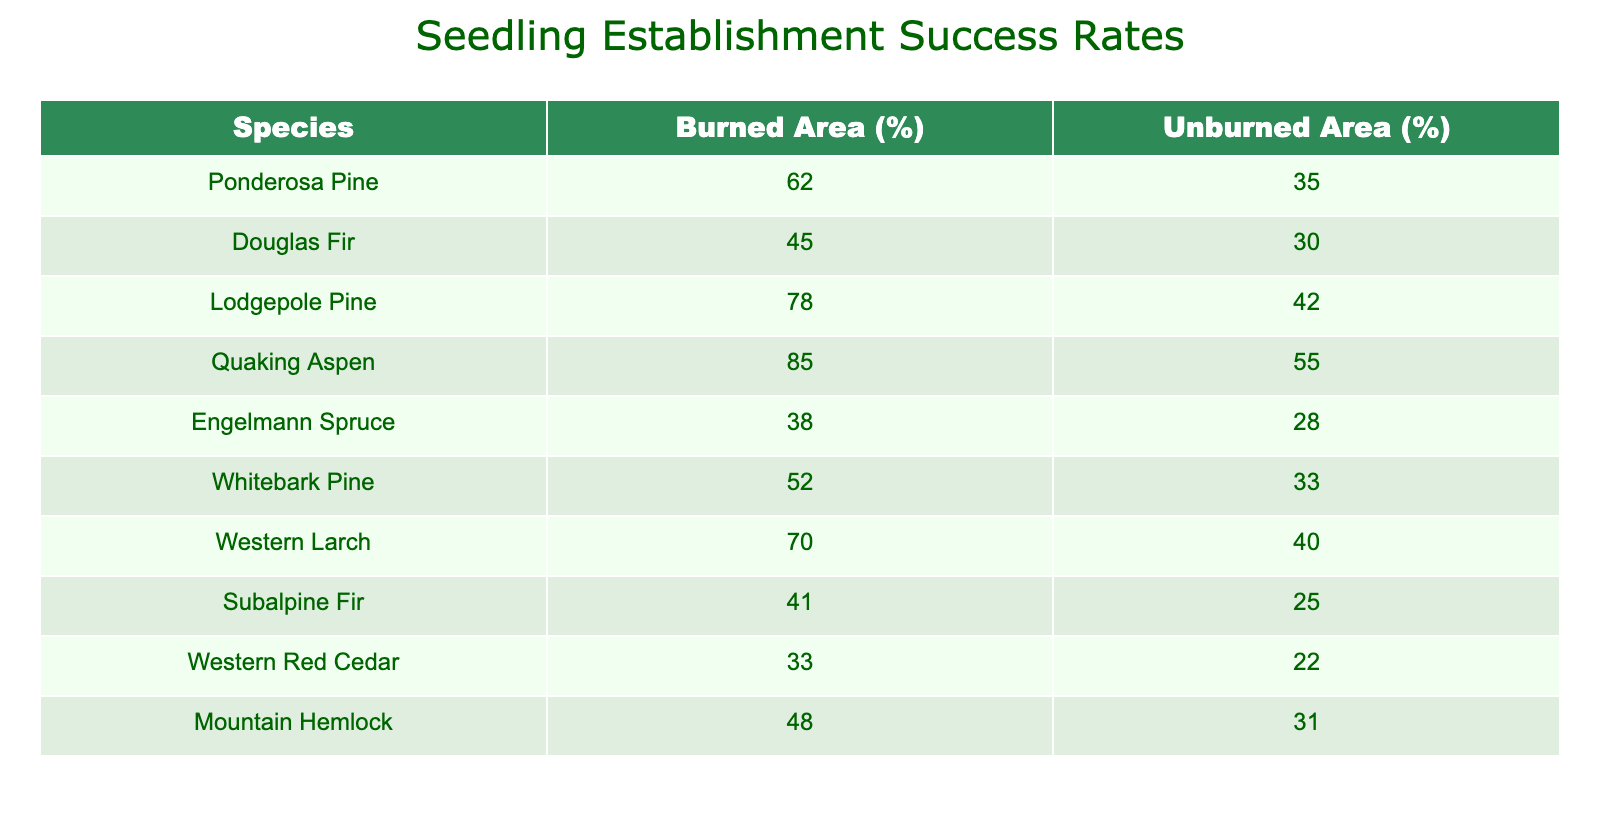What is the seedling establishment success rate for Quaking Aspen in burned areas? The table shows that the seedling establishment success rate for Quaking Aspen in burned areas is 85%.
Answer: 85 Which species has the highest seedling establishment success rate in unburned areas? The highest value in the "Unburned Area (%)" column is 55%, which corresponds to Quaking Aspen.
Answer: Quaking Aspen What is the difference in seedling establishment success rates between Lodgepole Pine in burned areas and in unburned areas? For Lodgepole Pine, the success rate in burned areas is 78% and in unburned areas is 42%. The difference is 78% - 42% = 36%.
Answer: 36 Do Engelmann Spruce have a higher success rate in burned areas than Whitebark Pine? Engelmann Spruce has a success rate of 38% in burned areas, while Whitebark Pine has a success rate of 52%. Since 38% is less than 52%, the statement is false.
Answer: No What is the average seedling establishment success rate for all species in burned areas? To find the average, we sum all the values in the "Burned Area (%)" column: 62 + 45 + 78 + 85 + 38 + 52 + 70 + 41 + 33 + 48 =  502. There are 10 species, so the average is 502 / 10 = 50.2%.
Answer: 50.2 Which species in burned areas has a success rate lower than 50%? Looking at the "Burned Area (%)" column, Engelmann Spruce (38%) and Subalpine Fir (41%) have rates lower than 50%.
Answer: Engelmann Spruce and Subalpine Fir Is the seedling establishment success rate for Mountain Hemlock higher than that of Western Red Cedar in unburned areas? Mountain Hemlock has a success rate of 31% in unburned areas, while Western Red Cedar has a success rate of 22%. Since 31% is greater than 22%, the answer is yes.
Answer: Yes What is the total seedling establishment success rate for all species in unburned areas? The total is the sum of all values in the "Unburned Area (%)" column: 35 + 30 + 42 + 55 + 28 + 33 + 40 + 25 + 22 + 31 =  361.
Answer: 361 What is the lowest seedling establishment success rate in burned areas? The lowest value in the "Burned Area (%)" column is 33%, corresponding to Western Red Cedar.
Answer: 33 